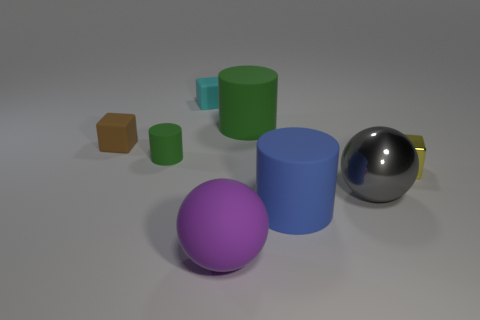Add 1 green things. How many objects exist? 9 Subtract all spheres. How many objects are left? 6 Add 3 small red objects. How many small red objects exist? 3 Subtract 0 yellow balls. How many objects are left? 8 Subtract all gray metallic objects. Subtract all large blue rubber objects. How many objects are left? 6 Add 8 large green cylinders. How many large green cylinders are left? 9 